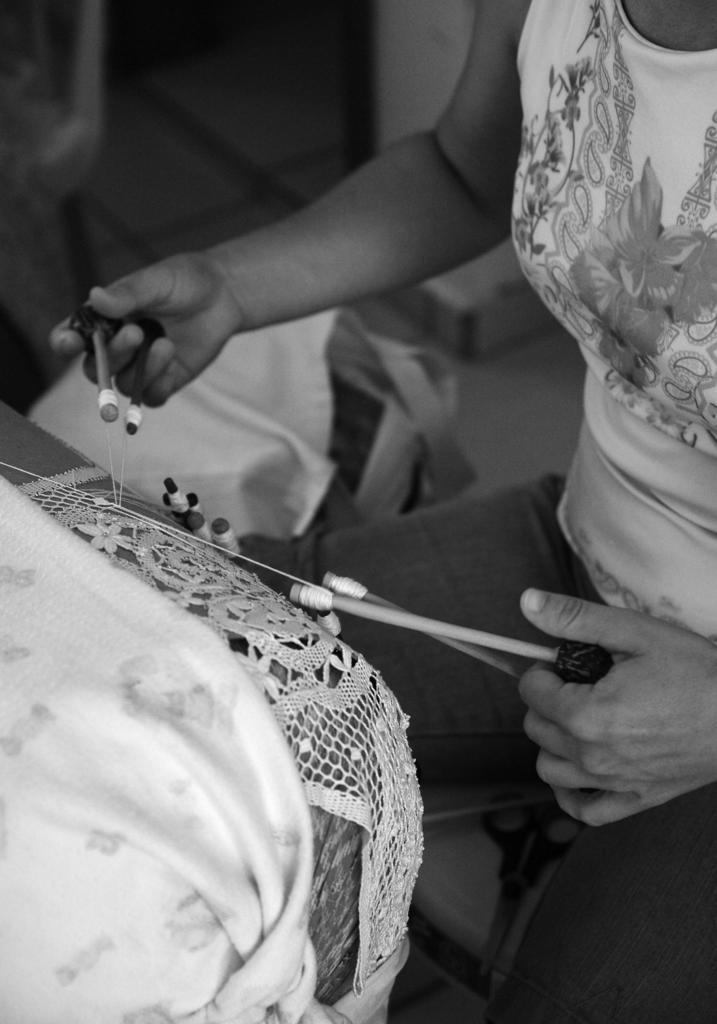Who is present in the image? There is a person in the image. Where is the person located in the image? The person is on the right side of the image. What activity is the person engaged in? The person is doing thread work. What type of furniture is on the left side of the image? There is a sofa on the left side of the image. What can be seen in the background of the image? There are objects in the background of the image. What direction is the person attacking in the image? There is no indication of an attack in the image; the person is doing thread work. What shape is the sofa in the image? The shape of the sofa is not specified in the image, only that it is present on the left side. 